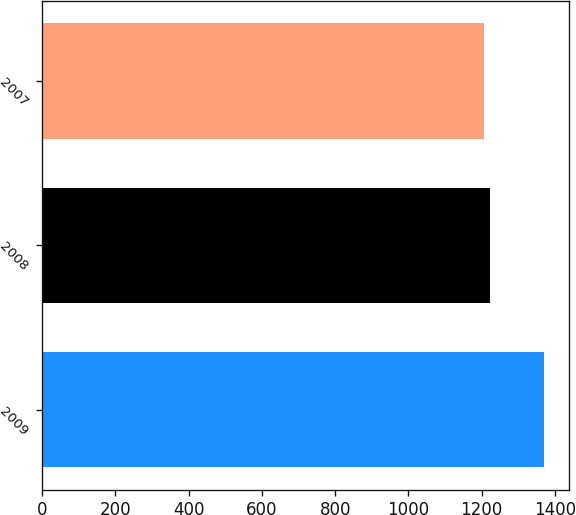<chart> <loc_0><loc_0><loc_500><loc_500><bar_chart><fcel>2009<fcel>2008<fcel>2007<nl><fcel>1371<fcel>1224<fcel>1207<nl></chart> 